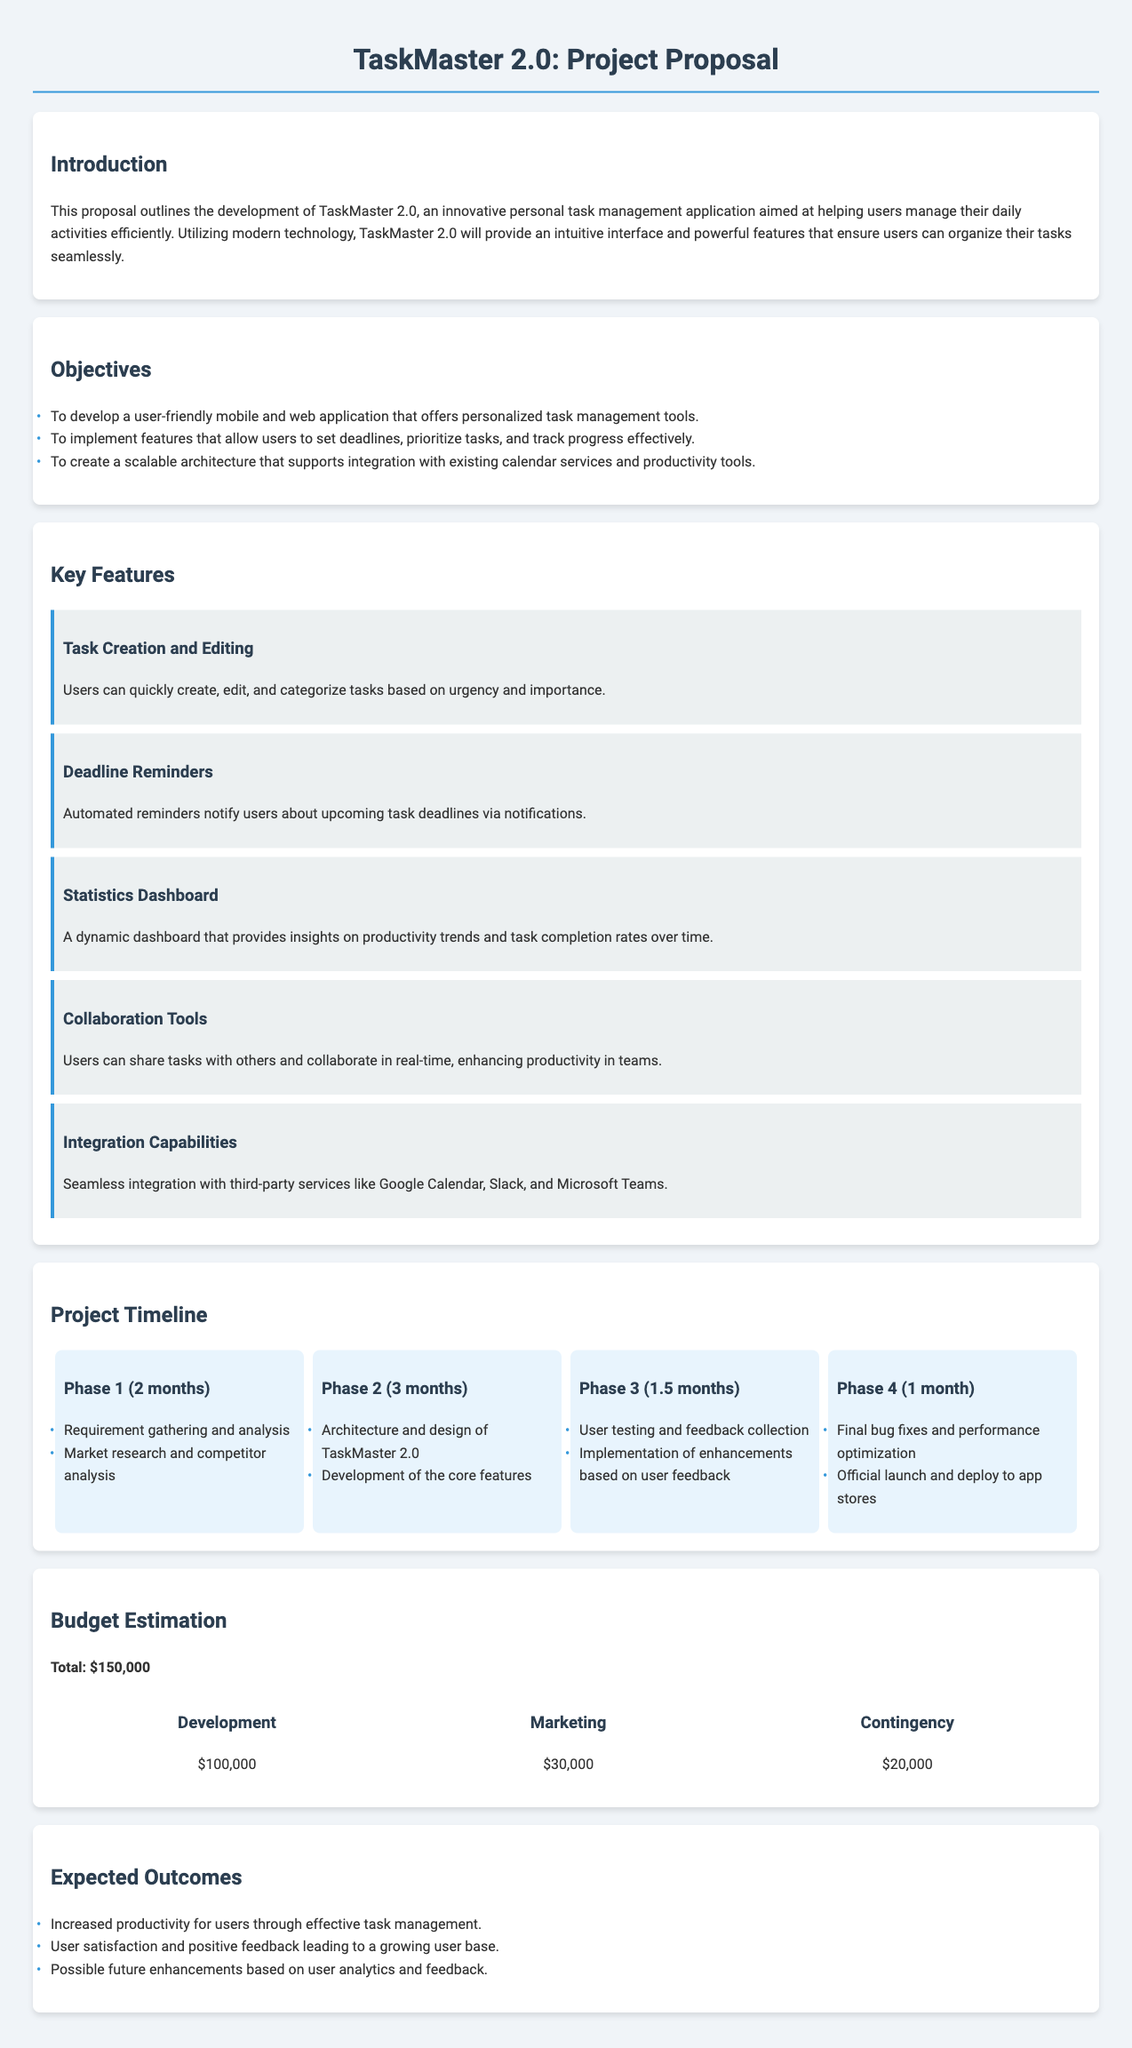What is the title of the project? The title of the project is stated in the document as "TaskMaster 2.0: Project Proposal."
Answer: TaskMaster 2.0: Project Proposal How long is Phase 3 scheduled to last? The timeline details specify that Phase 3 will last for 1.5 months.
Answer: 1.5 months What is the total budget estimated for the project? The budget estimation section indicates that the total budget is $150,000.
Answer: $150,000 What feature provides reminders about deadlines? The document mentions "Deadline Reminders" as a key feature that notifies users about upcoming task deadlines.
Answer: Deadline Reminders Which phase involves user testing? Phase 3 in the project timeline is where "User testing and feedback collection" is outlined as an activity.
Answer: Phase 3 What is the main objective regarding task management tools? One of the objectives listed is "To develop a user-friendly mobile and web application that offers personalized task management tools."
Answer: user-friendly mobile and web application How much is allocated for marketing in the budget? The document states that $30,000 is allocated for marketing.
Answer: $30,000 What is expected from user feedback? The expected outcome includes "User satisfaction and positive feedback leading to a growing user base."
Answer: User satisfaction and positive feedback What is the first activity mentioned in Phase 1? The first activity in Phase 1 is "Requirement gathering and analysis."
Answer: Requirement gathering and analysis 